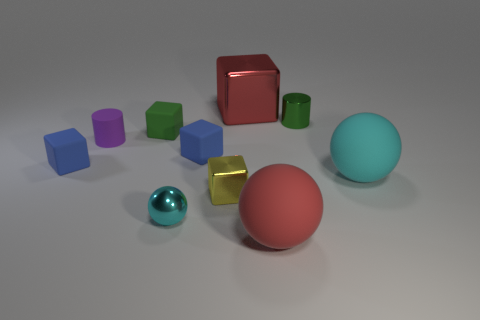Subtract 2 cubes. How many cubes are left? 3 Subtract all green cubes. How many cubes are left? 4 Subtract all big blocks. How many blocks are left? 4 Subtract all gray blocks. Subtract all gray balls. How many blocks are left? 5 Subtract all balls. How many objects are left? 7 Add 6 cyan matte things. How many cyan matte things exist? 7 Subtract 1 purple cylinders. How many objects are left? 9 Subtract all yellow metal blocks. Subtract all blue matte objects. How many objects are left? 7 Add 1 green rubber objects. How many green rubber objects are left? 2 